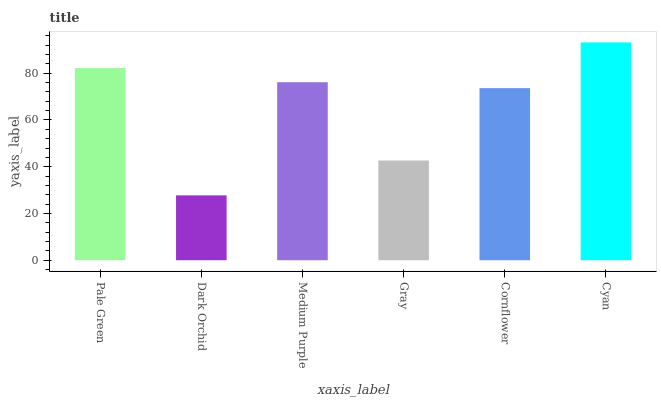Is Dark Orchid the minimum?
Answer yes or no. Yes. Is Cyan the maximum?
Answer yes or no. Yes. Is Medium Purple the minimum?
Answer yes or no. No. Is Medium Purple the maximum?
Answer yes or no. No. Is Medium Purple greater than Dark Orchid?
Answer yes or no. Yes. Is Dark Orchid less than Medium Purple?
Answer yes or no. Yes. Is Dark Orchid greater than Medium Purple?
Answer yes or no. No. Is Medium Purple less than Dark Orchid?
Answer yes or no. No. Is Medium Purple the high median?
Answer yes or no. Yes. Is Cornflower the low median?
Answer yes or no. Yes. Is Cornflower the high median?
Answer yes or no. No. Is Pale Green the low median?
Answer yes or no. No. 